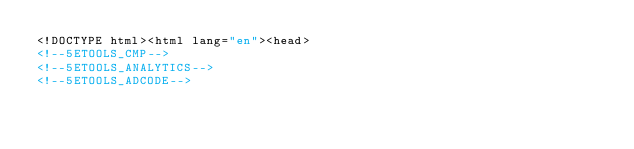Convert code to text. <code><loc_0><loc_0><loc_500><loc_500><_HTML_><!DOCTYPE html><html lang="en"><head>
<!--5ETOOLS_CMP-->
<!--5ETOOLS_ANALYTICS-->
<!--5ETOOLS_ADCODE--></code> 